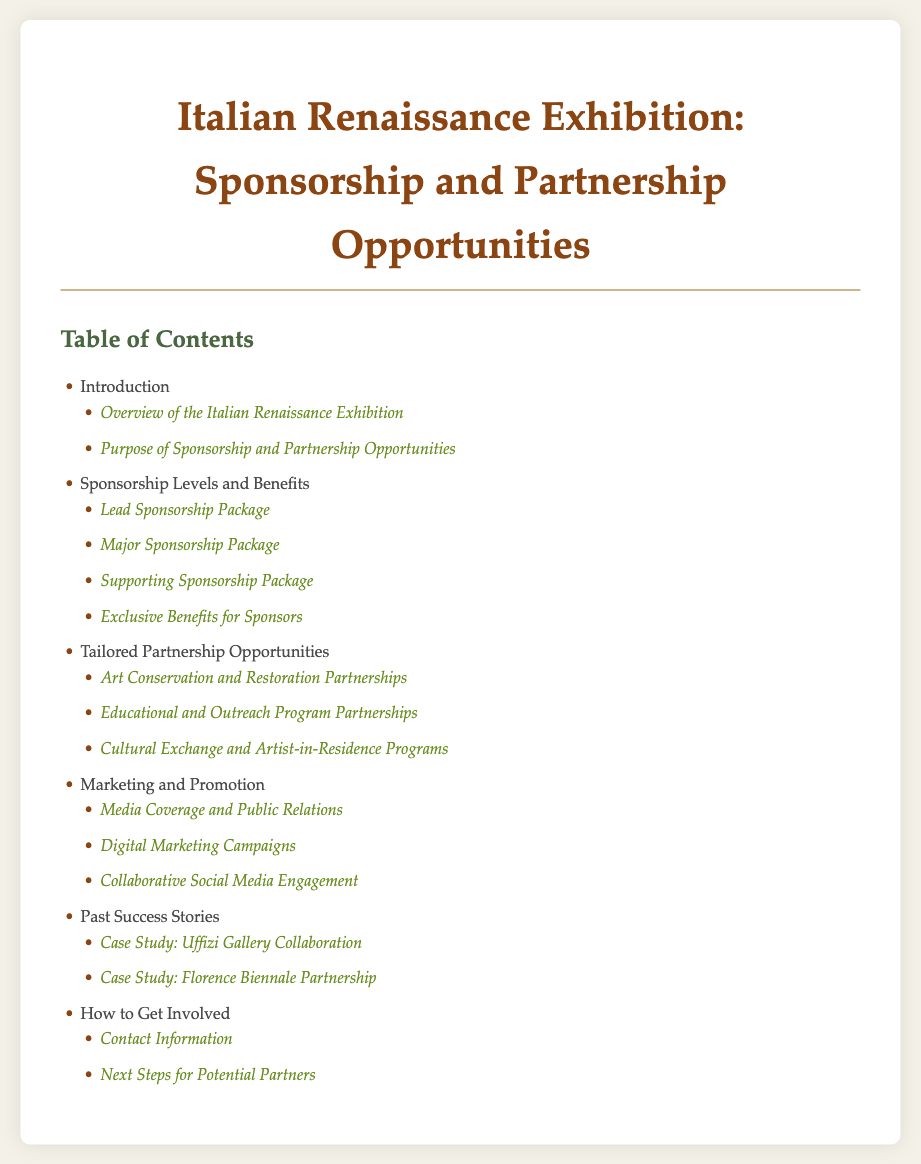What is the main purpose of the document? The document outlines the sponsorship and partnership opportunities for the upcoming Italian Renaissance exhibitions.
Answer: Sponsorship and partnership opportunities How many sponsorship packages are listed? There are four sponsorship packages detailed in the document.
Answer: Four What is one type of tailored partnership opportunity mentioned? The document mentions Art Conservation and Restoration Partnerships as a tailored partnership opportunity.
Answer: Art Conservation and Restoration Partnerships Which case study is featured as a past success story? The document includes a case study on the Uffizi Gallery Collaboration.
Answer: Uffizi Gallery Collaboration What section covers marketing strategies? The section titled "Marketing and Promotion" addresses marketing strategies for the exhibition.
Answer: Marketing and Promotion What information is provided in the "How to Get Involved" section? This section provides contact information and next steps for potential partners.
Answer: Contact information and next steps What are the exclusive benefits described for sponsors? The document states there is a section for exclusive benefits for sponsors.
Answer: Exclusive benefits for sponsors What is the color theme of the document's title? The titles in the document use a color theme based on shades of brown and green.
Answer: Brown and green 